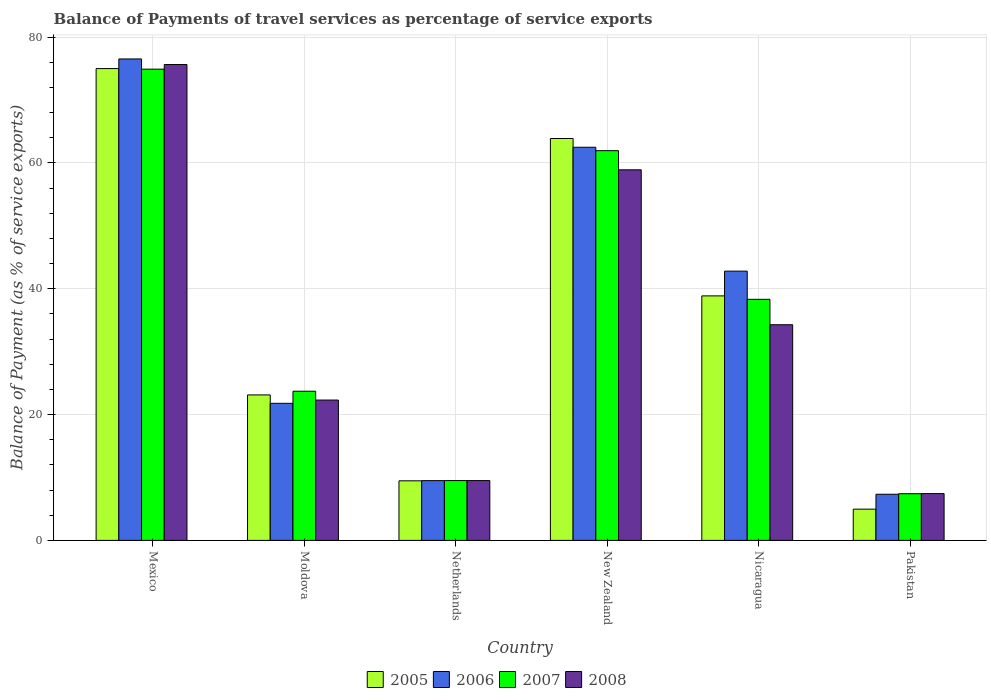How many different coloured bars are there?
Your answer should be compact. 4. How many groups of bars are there?
Give a very brief answer. 6. What is the label of the 2nd group of bars from the left?
Make the answer very short. Moldova. In how many cases, is the number of bars for a given country not equal to the number of legend labels?
Make the answer very short. 0. What is the balance of payments of travel services in 2006 in Nicaragua?
Make the answer very short. 42.81. Across all countries, what is the maximum balance of payments of travel services in 2006?
Your answer should be very brief. 76.54. Across all countries, what is the minimum balance of payments of travel services in 2008?
Your answer should be compact. 7.44. In which country was the balance of payments of travel services in 2005 minimum?
Offer a terse response. Pakistan. What is the total balance of payments of travel services in 2005 in the graph?
Provide a succinct answer. 215.34. What is the difference between the balance of payments of travel services in 2005 in Moldova and that in Nicaragua?
Offer a terse response. -15.74. What is the difference between the balance of payments of travel services in 2008 in New Zealand and the balance of payments of travel services in 2005 in Netherlands?
Your response must be concise. 49.44. What is the average balance of payments of travel services in 2008 per country?
Your response must be concise. 34.69. What is the difference between the balance of payments of travel services of/in 2005 and balance of payments of travel services of/in 2007 in New Zealand?
Offer a terse response. 1.93. What is the ratio of the balance of payments of travel services in 2005 in Netherlands to that in Pakistan?
Your answer should be very brief. 1.91. What is the difference between the highest and the second highest balance of payments of travel services in 2006?
Make the answer very short. -33.73. What is the difference between the highest and the lowest balance of payments of travel services in 2006?
Offer a very short reply. 69.21. In how many countries, is the balance of payments of travel services in 2007 greater than the average balance of payments of travel services in 2007 taken over all countries?
Provide a short and direct response. 3. What does the 4th bar from the left in Pakistan represents?
Provide a short and direct response. 2008. What does the 1st bar from the right in Nicaragua represents?
Provide a short and direct response. 2008. How many bars are there?
Your answer should be very brief. 24. How many countries are there in the graph?
Your answer should be very brief. 6. What is the difference between two consecutive major ticks on the Y-axis?
Offer a very short reply. 20. Are the values on the major ticks of Y-axis written in scientific E-notation?
Offer a terse response. No. How are the legend labels stacked?
Make the answer very short. Horizontal. What is the title of the graph?
Ensure brevity in your answer.  Balance of Payments of travel services as percentage of service exports. What is the label or title of the Y-axis?
Keep it short and to the point. Balance of Payment (as % of service exports). What is the Balance of Payment (as % of service exports) in 2005 in Mexico?
Your response must be concise. 75.01. What is the Balance of Payment (as % of service exports) in 2006 in Mexico?
Give a very brief answer. 76.54. What is the Balance of Payment (as % of service exports) in 2007 in Mexico?
Provide a succinct answer. 74.92. What is the Balance of Payment (as % of service exports) in 2008 in Mexico?
Your answer should be compact. 75.65. What is the Balance of Payment (as % of service exports) of 2005 in Moldova?
Give a very brief answer. 23.13. What is the Balance of Payment (as % of service exports) in 2006 in Moldova?
Give a very brief answer. 21.79. What is the Balance of Payment (as % of service exports) of 2007 in Moldova?
Your answer should be compact. 23.72. What is the Balance of Payment (as % of service exports) in 2008 in Moldova?
Your answer should be compact. 22.31. What is the Balance of Payment (as % of service exports) in 2005 in Netherlands?
Provide a succinct answer. 9.47. What is the Balance of Payment (as % of service exports) of 2006 in Netherlands?
Offer a terse response. 9.5. What is the Balance of Payment (as % of service exports) in 2007 in Netherlands?
Ensure brevity in your answer.  9.51. What is the Balance of Payment (as % of service exports) in 2008 in Netherlands?
Give a very brief answer. 9.51. What is the Balance of Payment (as % of service exports) in 2005 in New Zealand?
Provide a short and direct response. 63.89. What is the Balance of Payment (as % of service exports) in 2006 in New Zealand?
Provide a succinct answer. 62.5. What is the Balance of Payment (as % of service exports) in 2007 in New Zealand?
Provide a succinct answer. 61.96. What is the Balance of Payment (as % of service exports) of 2008 in New Zealand?
Keep it short and to the point. 58.91. What is the Balance of Payment (as % of service exports) of 2005 in Nicaragua?
Your answer should be compact. 38.87. What is the Balance of Payment (as % of service exports) in 2006 in Nicaragua?
Provide a short and direct response. 42.81. What is the Balance of Payment (as % of service exports) of 2007 in Nicaragua?
Your answer should be very brief. 38.33. What is the Balance of Payment (as % of service exports) of 2008 in Nicaragua?
Your response must be concise. 34.29. What is the Balance of Payment (as % of service exports) in 2005 in Pakistan?
Offer a terse response. 4.97. What is the Balance of Payment (as % of service exports) of 2006 in Pakistan?
Give a very brief answer. 7.34. What is the Balance of Payment (as % of service exports) in 2007 in Pakistan?
Give a very brief answer. 7.42. What is the Balance of Payment (as % of service exports) of 2008 in Pakistan?
Ensure brevity in your answer.  7.44. Across all countries, what is the maximum Balance of Payment (as % of service exports) of 2005?
Keep it short and to the point. 75.01. Across all countries, what is the maximum Balance of Payment (as % of service exports) of 2006?
Make the answer very short. 76.54. Across all countries, what is the maximum Balance of Payment (as % of service exports) in 2007?
Your answer should be very brief. 74.92. Across all countries, what is the maximum Balance of Payment (as % of service exports) in 2008?
Offer a very short reply. 75.65. Across all countries, what is the minimum Balance of Payment (as % of service exports) in 2005?
Offer a very short reply. 4.97. Across all countries, what is the minimum Balance of Payment (as % of service exports) of 2006?
Make the answer very short. 7.34. Across all countries, what is the minimum Balance of Payment (as % of service exports) of 2007?
Make the answer very short. 7.42. Across all countries, what is the minimum Balance of Payment (as % of service exports) in 2008?
Make the answer very short. 7.44. What is the total Balance of Payment (as % of service exports) of 2005 in the graph?
Keep it short and to the point. 215.34. What is the total Balance of Payment (as % of service exports) of 2006 in the graph?
Your answer should be very brief. 220.48. What is the total Balance of Payment (as % of service exports) of 2007 in the graph?
Provide a succinct answer. 215.85. What is the total Balance of Payment (as % of service exports) in 2008 in the graph?
Offer a very short reply. 208.11. What is the difference between the Balance of Payment (as % of service exports) of 2005 in Mexico and that in Moldova?
Ensure brevity in your answer.  51.88. What is the difference between the Balance of Payment (as % of service exports) of 2006 in Mexico and that in Moldova?
Provide a short and direct response. 54.75. What is the difference between the Balance of Payment (as % of service exports) of 2007 in Mexico and that in Moldova?
Your response must be concise. 51.2. What is the difference between the Balance of Payment (as % of service exports) of 2008 in Mexico and that in Moldova?
Offer a very short reply. 53.34. What is the difference between the Balance of Payment (as % of service exports) in 2005 in Mexico and that in Netherlands?
Your response must be concise. 65.54. What is the difference between the Balance of Payment (as % of service exports) of 2006 in Mexico and that in Netherlands?
Keep it short and to the point. 67.04. What is the difference between the Balance of Payment (as % of service exports) in 2007 in Mexico and that in Netherlands?
Offer a terse response. 65.41. What is the difference between the Balance of Payment (as % of service exports) of 2008 in Mexico and that in Netherlands?
Your answer should be very brief. 66.14. What is the difference between the Balance of Payment (as % of service exports) in 2005 in Mexico and that in New Zealand?
Give a very brief answer. 11.12. What is the difference between the Balance of Payment (as % of service exports) in 2006 in Mexico and that in New Zealand?
Your response must be concise. 14.04. What is the difference between the Balance of Payment (as % of service exports) of 2007 in Mexico and that in New Zealand?
Offer a terse response. 12.96. What is the difference between the Balance of Payment (as % of service exports) in 2008 in Mexico and that in New Zealand?
Keep it short and to the point. 16.74. What is the difference between the Balance of Payment (as % of service exports) of 2005 in Mexico and that in Nicaragua?
Your answer should be compact. 36.14. What is the difference between the Balance of Payment (as % of service exports) in 2006 in Mexico and that in Nicaragua?
Your answer should be very brief. 33.73. What is the difference between the Balance of Payment (as % of service exports) of 2007 in Mexico and that in Nicaragua?
Keep it short and to the point. 36.59. What is the difference between the Balance of Payment (as % of service exports) of 2008 in Mexico and that in Nicaragua?
Your response must be concise. 41.37. What is the difference between the Balance of Payment (as % of service exports) of 2005 in Mexico and that in Pakistan?
Ensure brevity in your answer.  70.04. What is the difference between the Balance of Payment (as % of service exports) of 2006 in Mexico and that in Pakistan?
Keep it short and to the point. 69.21. What is the difference between the Balance of Payment (as % of service exports) of 2007 in Mexico and that in Pakistan?
Keep it short and to the point. 67.5. What is the difference between the Balance of Payment (as % of service exports) in 2008 in Mexico and that in Pakistan?
Offer a very short reply. 68.21. What is the difference between the Balance of Payment (as % of service exports) in 2005 in Moldova and that in Netherlands?
Make the answer very short. 13.66. What is the difference between the Balance of Payment (as % of service exports) in 2006 in Moldova and that in Netherlands?
Provide a short and direct response. 12.29. What is the difference between the Balance of Payment (as % of service exports) in 2007 in Moldova and that in Netherlands?
Offer a very short reply. 14.21. What is the difference between the Balance of Payment (as % of service exports) of 2008 in Moldova and that in Netherlands?
Your response must be concise. 12.8. What is the difference between the Balance of Payment (as % of service exports) of 2005 in Moldova and that in New Zealand?
Keep it short and to the point. -40.76. What is the difference between the Balance of Payment (as % of service exports) of 2006 in Moldova and that in New Zealand?
Your response must be concise. -40.71. What is the difference between the Balance of Payment (as % of service exports) in 2007 in Moldova and that in New Zealand?
Make the answer very short. -38.24. What is the difference between the Balance of Payment (as % of service exports) in 2008 in Moldova and that in New Zealand?
Your answer should be very brief. -36.6. What is the difference between the Balance of Payment (as % of service exports) of 2005 in Moldova and that in Nicaragua?
Ensure brevity in your answer.  -15.74. What is the difference between the Balance of Payment (as % of service exports) of 2006 in Moldova and that in Nicaragua?
Offer a very short reply. -21.01. What is the difference between the Balance of Payment (as % of service exports) of 2007 in Moldova and that in Nicaragua?
Give a very brief answer. -14.61. What is the difference between the Balance of Payment (as % of service exports) of 2008 in Moldova and that in Nicaragua?
Keep it short and to the point. -11.97. What is the difference between the Balance of Payment (as % of service exports) in 2005 in Moldova and that in Pakistan?
Make the answer very short. 18.16. What is the difference between the Balance of Payment (as % of service exports) in 2006 in Moldova and that in Pakistan?
Keep it short and to the point. 14.46. What is the difference between the Balance of Payment (as % of service exports) in 2007 in Moldova and that in Pakistan?
Offer a very short reply. 16.3. What is the difference between the Balance of Payment (as % of service exports) of 2008 in Moldova and that in Pakistan?
Your answer should be compact. 14.87. What is the difference between the Balance of Payment (as % of service exports) in 2005 in Netherlands and that in New Zealand?
Your answer should be very brief. -54.42. What is the difference between the Balance of Payment (as % of service exports) in 2006 in Netherlands and that in New Zealand?
Keep it short and to the point. -53. What is the difference between the Balance of Payment (as % of service exports) in 2007 in Netherlands and that in New Zealand?
Offer a terse response. -52.45. What is the difference between the Balance of Payment (as % of service exports) of 2008 in Netherlands and that in New Zealand?
Ensure brevity in your answer.  -49.41. What is the difference between the Balance of Payment (as % of service exports) in 2005 in Netherlands and that in Nicaragua?
Provide a short and direct response. -29.4. What is the difference between the Balance of Payment (as % of service exports) in 2006 in Netherlands and that in Nicaragua?
Your response must be concise. -33.31. What is the difference between the Balance of Payment (as % of service exports) of 2007 in Netherlands and that in Nicaragua?
Your answer should be very brief. -28.82. What is the difference between the Balance of Payment (as % of service exports) in 2008 in Netherlands and that in Nicaragua?
Your answer should be very brief. -24.78. What is the difference between the Balance of Payment (as % of service exports) in 2005 in Netherlands and that in Pakistan?
Offer a terse response. 4.51. What is the difference between the Balance of Payment (as % of service exports) of 2006 in Netherlands and that in Pakistan?
Your answer should be very brief. 2.16. What is the difference between the Balance of Payment (as % of service exports) in 2007 in Netherlands and that in Pakistan?
Your answer should be compact. 2.09. What is the difference between the Balance of Payment (as % of service exports) of 2008 in Netherlands and that in Pakistan?
Your answer should be compact. 2.07. What is the difference between the Balance of Payment (as % of service exports) of 2005 in New Zealand and that in Nicaragua?
Your answer should be compact. 25.02. What is the difference between the Balance of Payment (as % of service exports) in 2006 in New Zealand and that in Nicaragua?
Your response must be concise. 19.69. What is the difference between the Balance of Payment (as % of service exports) of 2007 in New Zealand and that in Nicaragua?
Your answer should be compact. 23.63. What is the difference between the Balance of Payment (as % of service exports) in 2008 in New Zealand and that in Nicaragua?
Your answer should be very brief. 24.63. What is the difference between the Balance of Payment (as % of service exports) in 2005 in New Zealand and that in Pakistan?
Ensure brevity in your answer.  58.93. What is the difference between the Balance of Payment (as % of service exports) in 2006 in New Zealand and that in Pakistan?
Your answer should be compact. 55.17. What is the difference between the Balance of Payment (as % of service exports) in 2007 in New Zealand and that in Pakistan?
Ensure brevity in your answer.  54.54. What is the difference between the Balance of Payment (as % of service exports) in 2008 in New Zealand and that in Pakistan?
Provide a succinct answer. 51.47. What is the difference between the Balance of Payment (as % of service exports) of 2005 in Nicaragua and that in Pakistan?
Provide a short and direct response. 33.91. What is the difference between the Balance of Payment (as % of service exports) in 2006 in Nicaragua and that in Pakistan?
Offer a very short reply. 35.47. What is the difference between the Balance of Payment (as % of service exports) in 2007 in Nicaragua and that in Pakistan?
Provide a short and direct response. 30.91. What is the difference between the Balance of Payment (as % of service exports) in 2008 in Nicaragua and that in Pakistan?
Offer a very short reply. 26.85. What is the difference between the Balance of Payment (as % of service exports) in 2005 in Mexico and the Balance of Payment (as % of service exports) in 2006 in Moldova?
Your answer should be compact. 53.22. What is the difference between the Balance of Payment (as % of service exports) in 2005 in Mexico and the Balance of Payment (as % of service exports) in 2007 in Moldova?
Provide a short and direct response. 51.29. What is the difference between the Balance of Payment (as % of service exports) in 2005 in Mexico and the Balance of Payment (as % of service exports) in 2008 in Moldova?
Keep it short and to the point. 52.7. What is the difference between the Balance of Payment (as % of service exports) of 2006 in Mexico and the Balance of Payment (as % of service exports) of 2007 in Moldova?
Your response must be concise. 52.82. What is the difference between the Balance of Payment (as % of service exports) in 2006 in Mexico and the Balance of Payment (as % of service exports) in 2008 in Moldova?
Provide a short and direct response. 54.23. What is the difference between the Balance of Payment (as % of service exports) of 2007 in Mexico and the Balance of Payment (as % of service exports) of 2008 in Moldova?
Make the answer very short. 52.61. What is the difference between the Balance of Payment (as % of service exports) in 2005 in Mexico and the Balance of Payment (as % of service exports) in 2006 in Netherlands?
Offer a very short reply. 65.51. What is the difference between the Balance of Payment (as % of service exports) of 2005 in Mexico and the Balance of Payment (as % of service exports) of 2007 in Netherlands?
Keep it short and to the point. 65.5. What is the difference between the Balance of Payment (as % of service exports) in 2005 in Mexico and the Balance of Payment (as % of service exports) in 2008 in Netherlands?
Your answer should be compact. 65.5. What is the difference between the Balance of Payment (as % of service exports) of 2006 in Mexico and the Balance of Payment (as % of service exports) of 2007 in Netherlands?
Provide a short and direct response. 67.03. What is the difference between the Balance of Payment (as % of service exports) of 2006 in Mexico and the Balance of Payment (as % of service exports) of 2008 in Netherlands?
Provide a short and direct response. 67.03. What is the difference between the Balance of Payment (as % of service exports) of 2007 in Mexico and the Balance of Payment (as % of service exports) of 2008 in Netherlands?
Ensure brevity in your answer.  65.41. What is the difference between the Balance of Payment (as % of service exports) in 2005 in Mexico and the Balance of Payment (as % of service exports) in 2006 in New Zealand?
Offer a terse response. 12.51. What is the difference between the Balance of Payment (as % of service exports) in 2005 in Mexico and the Balance of Payment (as % of service exports) in 2007 in New Zealand?
Your answer should be very brief. 13.05. What is the difference between the Balance of Payment (as % of service exports) in 2005 in Mexico and the Balance of Payment (as % of service exports) in 2008 in New Zealand?
Your answer should be compact. 16.09. What is the difference between the Balance of Payment (as % of service exports) of 2006 in Mexico and the Balance of Payment (as % of service exports) of 2007 in New Zealand?
Make the answer very short. 14.58. What is the difference between the Balance of Payment (as % of service exports) in 2006 in Mexico and the Balance of Payment (as % of service exports) in 2008 in New Zealand?
Keep it short and to the point. 17.63. What is the difference between the Balance of Payment (as % of service exports) of 2007 in Mexico and the Balance of Payment (as % of service exports) of 2008 in New Zealand?
Your response must be concise. 16. What is the difference between the Balance of Payment (as % of service exports) in 2005 in Mexico and the Balance of Payment (as % of service exports) in 2006 in Nicaragua?
Provide a short and direct response. 32.2. What is the difference between the Balance of Payment (as % of service exports) of 2005 in Mexico and the Balance of Payment (as % of service exports) of 2007 in Nicaragua?
Your response must be concise. 36.68. What is the difference between the Balance of Payment (as % of service exports) of 2005 in Mexico and the Balance of Payment (as % of service exports) of 2008 in Nicaragua?
Offer a terse response. 40.72. What is the difference between the Balance of Payment (as % of service exports) of 2006 in Mexico and the Balance of Payment (as % of service exports) of 2007 in Nicaragua?
Offer a terse response. 38.22. What is the difference between the Balance of Payment (as % of service exports) in 2006 in Mexico and the Balance of Payment (as % of service exports) in 2008 in Nicaragua?
Provide a succinct answer. 42.26. What is the difference between the Balance of Payment (as % of service exports) in 2007 in Mexico and the Balance of Payment (as % of service exports) in 2008 in Nicaragua?
Ensure brevity in your answer.  40.63. What is the difference between the Balance of Payment (as % of service exports) in 2005 in Mexico and the Balance of Payment (as % of service exports) in 2006 in Pakistan?
Your answer should be very brief. 67.67. What is the difference between the Balance of Payment (as % of service exports) in 2005 in Mexico and the Balance of Payment (as % of service exports) in 2007 in Pakistan?
Give a very brief answer. 67.59. What is the difference between the Balance of Payment (as % of service exports) of 2005 in Mexico and the Balance of Payment (as % of service exports) of 2008 in Pakistan?
Your answer should be compact. 67.57. What is the difference between the Balance of Payment (as % of service exports) of 2006 in Mexico and the Balance of Payment (as % of service exports) of 2007 in Pakistan?
Make the answer very short. 69.12. What is the difference between the Balance of Payment (as % of service exports) in 2006 in Mexico and the Balance of Payment (as % of service exports) in 2008 in Pakistan?
Give a very brief answer. 69.1. What is the difference between the Balance of Payment (as % of service exports) in 2007 in Mexico and the Balance of Payment (as % of service exports) in 2008 in Pakistan?
Your answer should be compact. 67.48. What is the difference between the Balance of Payment (as % of service exports) in 2005 in Moldova and the Balance of Payment (as % of service exports) in 2006 in Netherlands?
Make the answer very short. 13.63. What is the difference between the Balance of Payment (as % of service exports) in 2005 in Moldova and the Balance of Payment (as % of service exports) in 2007 in Netherlands?
Give a very brief answer. 13.62. What is the difference between the Balance of Payment (as % of service exports) in 2005 in Moldova and the Balance of Payment (as % of service exports) in 2008 in Netherlands?
Provide a succinct answer. 13.62. What is the difference between the Balance of Payment (as % of service exports) of 2006 in Moldova and the Balance of Payment (as % of service exports) of 2007 in Netherlands?
Your answer should be very brief. 12.28. What is the difference between the Balance of Payment (as % of service exports) of 2006 in Moldova and the Balance of Payment (as % of service exports) of 2008 in Netherlands?
Your answer should be very brief. 12.28. What is the difference between the Balance of Payment (as % of service exports) of 2007 in Moldova and the Balance of Payment (as % of service exports) of 2008 in Netherlands?
Provide a succinct answer. 14.21. What is the difference between the Balance of Payment (as % of service exports) in 2005 in Moldova and the Balance of Payment (as % of service exports) in 2006 in New Zealand?
Offer a very short reply. -39.37. What is the difference between the Balance of Payment (as % of service exports) in 2005 in Moldova and the Balance of Payment (as % of service exports) in 2007 in New Zealand?
Keep it short and to the point. -38.83. What is the difference between the Balance of Payment (as % of service exports) of 2005 in Moldova and the Balance of Payment (as % of service exports) of 2008 in New Zealand?
Provide a succinct answer. -35.79. What is the difference between the Balance of Payment (as % of service exports) of 2006 in Moldova and the Balance of Payment (as % of service exports) of 2007 in New Zealand?
Your answer should be compact. -40.16. What is the difference between the Balance of Payment (as % of service exports) of 2006 in Moldova and the Balance of Payment (as % of service exports) of 2008 in New Zealand?
Keep it short and to the point. -37.12. What is the difference between the Balance of Payment (as % of service exports) of 2007 in Moldova and the Balance of Payment (as % of service exports) of 2008 in New Zealand?
Offer a terse response. -35.2. What is the difference between the Balance of Payment (as % of service exports) of 2005 in Moldova and the Balance of Payment (as % of service exports) of 2006 in Nicaragua?
Your response must be concise. -19.68. What is the difference between the Balance of Payment (as % of service exports) in 2005 in Moldova and the Balance of Payment (as % of service exports) in 2007 in Nicaragua?
Give a very brief answer. -15.2. What is the difference between the Balance of Payment (as % of service exports) in 2005 in Moldova and the Balance of Payment (as % of service exports) in 2008 in Nicaragua?
Offer a terse response. -11.16. What is the difference between the Balance of Payment (as % of service exports) of 2006 in Moldova and the Balance of Payment (as % of service exports) of 2007 in Nicaragua?
Offer a terse response. -16.53. What is the difference between the Balance of Payment (as % of service exports) in 2006 in Moldova and the Balance of Payment (as % of service exports) in 2008 in Nicaragua?
Provide a short and direct response. -12.49. What is the difference between the Balance of Payment (as % of service exports) of 2007 in Moldova and the Balance of Payment (as % of service exports) of 2008 in Nicaragua?
Your response must be concise. -10.57. What is the difference between the Balance of Payment (as % of service exports) in 2005 in Moldova and the Balance of Payment (as % of service exports) in 2006 in Pakistan?
Offer a terse response. 15.79. What is the difference between the Balance of Payment (as % of service exports) in 2005 in Moldova and the Balance of Payment (as % of service exports) in 2007 in Pakistan?
Provide a succinct answer. 15.71. What is the difference between the Balance of Payment (as % of service exports) in 2005 in Moldova and the Balance of Payment (as % of service exports) in 2008 in Pakistan?
Offer a very short reply. 15.69. What is the difference between the Balance of Payment (as % of service exports) in 2006 in Moldova and the Balance of Payment (as % of service exports) in 2007 in Pakistan?
Your response must be concise. 14.37. What is the difference between the Balance of Payment (as % of service exports) in 2006 in Moldova and the Balance of Payment (as % of service exports) in 2008 in Pakistan?
Make the answer very short. 14.35. What is the difference between the Balance of Payment (as % of service exports) of 2007 in Moldova and the Balance of Payment (as % of service exports) of 2008 in Pakistan?
Ensure brevity in your answer.  16.28. What is the difference between the Balance of Payment (as % of service exports) of 2005 in Netherlands and the Balance of Payment (as % of service exports) of 2006 in New Zealand?
Offer a very short reply. -53.03. What is the difference between the Balance of Payment (as % of service exports) in 2005 in Netherlands and the Balance of Payment (as % of service exports) in 2007 in New Zealand?
Make the answer very short. -52.49. What is the difference between the Balance of Payment (as % of service exports) of 2005 in Netherlands and the Balance of Payment (as % of service exports) of 2008 in New Zealand?
Provide a succinct answer. -49.44. What is the difference between the Balance of Payment (as % of service exports) in 2006 in Netherlands and the Balance of Payment (as % of service exports) in 2007 in New Zealand?
Make the answer very short. -52.46. What is the difference between the Balance of Payment (as % of service exports) in 2006 in Netherlands and the Balance of Payment (as % of service exports) in 2008 in New Zealand?
Give a very brief answer. -49.42. What is the difference between the Balance of Payment (as % of service exports) in 2007 in Netherlands and the Balance of Payment (as % of service exports) in 2008 in New Zealand?
Your answer should be compact. -49.41. What is the difference between the Balance of Payment (as % of service exports) of 2005 in Netherlands and the Balance of Payment (as % of service exports) of 2006 in Nicaragua?
Provide a succinct answer. -33.34. What is the difference between the Balance of Payment (as % of service exports) of 2005 in Netherlands and the Balance of Payment (as % of service exports) of 2007 in Nicaragua?
Your response must be concise. -28.85. What is the difference between the Balance of Payment (as % of service exports) of 2005 in Netherlands and the Balance of Payment (as % of service exports) of 2008 in Nicaragua?
Ensure brevity in your answer.  -24.81. What is the difference between the Balance of Payment (as % of service exports) in 2006 in Netherlands and the Balance of Payment (as % of service exports) in 2007 in Nicaragua?
Ensure brevity in your answer.  -28.83. What is the difference between the Balance of Payment (as % of service exports) of 2006 in Netherlands and the Balance of Payment (as % of service exports) of 2008 in Nicaragua?
Your answer should be very brief. -24.79. What is the difference between the Balance of Payment (as % of service exports) in 2007 in Netherlands and the Balance of Payment (as % of service exports) in 2008 in Nicaragua?
Keep it short and to the point. -24.78. What is the difference between the Balance of Payment (as % of service exports) of 2005 in Netherlands and the Balance of Payment (as % of service exports) of 2006 in Pakistan?
Make the answer very short. 2.14. What is the difference between the Balance of Payment (as % of service exports) in 2005 in Netherlands and the Balance of Payment (as % of service exports) in 2007 in Pakistan?
Give a very brief answer. 2.05. What is the difference between the Balance of Payment (as % of service exports) in 2005 in Netherlands and the Balance of Payment (as % of service exports) in 2008 in Pakistan?
Your answer should be very brief. 2.03. What is the difference between the Balance of Payment (as % of service exports) of 2006 in Netherlands and the Balance of Payment (as % of service exports) of 2007 in Pakistan?
Give a very brief answer. 2.08. What is the difference between the Balance of Payment (as % of service exports) in 2006 in Netherlands and the Balance of Payment (as % of service exports) in 2008 in Pakistan?
Make the answer very short. 2.06. What is the difference between the Balance of Payment (as % of service exports) in 2007 in Netherlands and the Balance of Payment (as % of service exports) in 2008 in Pakistan?
Your answer should be very brief. 2.07. What is the difference between the Balance of Payment (as % of service exports) in 2005 in New Zealand and the Balance of Payment (as % of service exports) in 2006 in Nicaragua?
Offer a very short reply. 21.09. What is the difference between the Balance of Payment (as % of service exports) of 2005 in New Zealand and the Balance of Payment (as % of service exports) of 2007 in Nicaragua?
Offer a terse response. 25.57. What is the difference between the Balance of Payment (as % of service exports) in 2005 in New Zealand and the Balance of Payment (as % of service exports) in 2008 in Nicaragua?
Your answer should be very brief. 29.61. What is the difference between the Balance of Payment (as % of service exports) of 2006 in New Zealand and the Balance of Payment (as % of service exports) of 2007 in Nicaragua?
Ensure brevity in your answer.  24.18. What is the difference between the Balance of Payment (as % of service exports) in 2006 in New Zealand and the Balance of Payment (as % of service exports) in 2008 in Nicaragua?
Offer a terse response. 28.21. What is the difference between the Balance of Payment (as % of service exports) of 2007 in New Zealand and the Balance of Payment (as % of service exports) of 2008 in Nicaragua?
Keep it short and to the point. 27.67. What is the difference between the Balance of Payment (as % of service exports) in 2005 in New Zealand and the Balance of Payment (as % of service exports) in 2006 in Pakistan?
Offer a very short reply. 56.56. What is the difference between the Balance of Payment (as % of service exports) of 2005 in New Zealand and the Balance of Payment (as % of service exports) of 2007 in Pakistan?
Provide a short and direct response. 56.47. What is the difference between the Balance of Payment (as % of service exports) of 2005 in New Zealand and the Balance of Payment (as % of service exports) of 2008 in Pakistan?
Offer a terse response. 56.45. What is the difference between the Balance of Payment (as % of service exports) of 2006 in New Zealand and the Balance of Payment (as % of service exports) of 2007 in Pakistan?
Ensure brevity in your answer.  55.08. What is the difference between the Balance of Payment (as % of service exports) in 2006 in New Zealand and the Balance of Payment (as % of service exports) in 2008 in Pakistan?
Your answer should be very brief. 55.06. What is the difference between the Balance of Payment (as % of service exports) of 2007 in New Zealand and the Balance of Payment (as % of service exports) of 2008 in Pakistan?
Provide a short and direct response. 54.52. What is the difference between the Balance of Payment (as % of service exports) in 2005 in Nicaragua and the Balance of Payment (as % of service exports) in 2006 in Pakistan?
Provide a succinct answer. 31.54. What is the difference between the Balance of Payment (as % of service exports) in 2005 in Nicaragua and the Balance of Payment (as % of service exports) in 2007 in Pakistan?
Offer a very short reply. 31.46. What is the difference between the Balance of Payment (as % of service exports) in 2005 in Nicaragua and the Balance of Payment (as % of service exports) in 2008 in Pakistan?
Ensure brevity in your answer.  31.43. What is the difference between the Balance of Payment (as % of service exports) of 2006 in Nicaragua and the Balance of Payment (as % of service exports) of 2007 in Pakistan?
Offer a very short reply. 35.39. What is the difference between the Balance of Payment (as % of service exports) of 2006 in Nicaragua and the Balance of Payment (as % of service exports) of 2008 in Pakistan?
Give a very brief answer. 35.37. What is the difference between the Balance of Payment (as % of service exports) in 2007 in Nicaragua and the Balance of Payment (as % of service exports) in 2008 in Pakistan?
Your response must be concise. 30.89. What is the average Balance of Payment (as % of service exports) of 2005 per country?
Make the answer very short. 35.89. What is the average Balance of Payment (as % of service exports) in 2006 per country?
Provide a short and direct response. 36.75. What is the average Balance of Payment (as % of service exports) in 2007 per country?
Keep it short and to the point. 35.97. What is the average Balance of Payment (as % of service exports) in 2008 per country?
Your response must be concise. 34.69. What is the difference between the Balance of Payment (as % of service exports) in 2005 and Balance of Payment (as % of service exports) in 2006 in Mexico?
Provide a short and direct response. -1.53. What is the difference between the Balance of Payment (as % of service exports) of 2005 and Balance of Payment (as % of service exports) of 2007 in Mexico?
Your response must be concise. 0.09. What is the difference between the Balance of Payment (as % of service exports) of 2005 and Balance of Payment (as % of service exports) of 2008 in Mexico?
Offer a terse response. -0.64. What is the difference between the Balance of Payment (as % of service exports) of 2006 and Balance of Payment (as % of service exports) of 2007 in Mexico?
Keep it short and to the point. 1.62. What is the difference between the Balance of Payment (as % of service exports) of 2006 and Balance of Payment (as % of service exports) of 2008 in Mexico?
Keep it short and to the point. 0.89. What is the difference between the Balance of Payment (as % of service exports) in 2007 and Balance of Payment (as % of service exports) in 2008 in Mexico?
Keep it short and to the point. -0.73. What is the difference between the Balance of Payment (as % of service exports) of 2005 and Balance of Payment (as % of service exports) of 2006 in Moldova?
Give a very brief answer. 1.34. What is the difference between the Balance of Payment (as % of service exports) of 2005 and Balance of Payment (as % of service exports) of 2007 in Moldova?
Your response must be concise. -0.59. What is the difference between the Balance of Payment (as % of service exports) of 2005 and Balance of Payment (as % of service exports) of 2008 in Moldova?
Provide a short and direct response. 0.82. What is the difference between the Balance of Payment (as % of service exports) in 2006 and Balance of Payment (as % of service exports) in 2007 in Moldova?
Offer a terse response. -1.92. What is the difference between the Balance of Payment (as % of service exports) in 2006 and Balance of Payment (as % of service exports) in 2008 in Moldova?
Your answer should be compact. -0.52. What is the difference between the Balance of Payment (as % of service exports) in 2007 and Balance of Payment (as % of service exports) in 2008 in Moldova?
Ensure brevity in your answer.  1.41. What is the difference between the Balance of Payment (as % of service exports) in 2005 and Balance of Payment (as % of service exports) in 2006 in Netherlands?
Your response must be concise. -0.03. What is the difference between the Balance of Payment (as % of service exports) of 2005 and Balance of Payment (as % of service exports) of 2007 in Netherlands?
Provide a short and direct response. -0.04. What is the difference between the Balance of Payment (as % of service exports) of 2005 and Balance of Payment (as % of service exports) of 2008 in Netherlands?
Make the answer very short. -0.04. What is the difference between the Balance of Payment (as % of service exports) in 2006 and Balance of Payment (as % of service exports) in 2007 in Netherlands?
Keep it short and to the point. -0.01. What is the difference between the Balance of Payment (as % of service exports) of 2006 and Balance of Payment (as % of service exports) of 2008 in Netherlands?
Your answer should be very brief. -0.01. What is the difference between the Balance of Payment (as % of service exports) in 2007 and Balance of Payment (as % of service exports) in 2008 in Netherlands?
Make the answer very short. -0. What is the difference between the Balance of Payment (as % of service exports) in 2005 and Balance of Payment (as % of service exports) in 2006 in New Zealand?
Your answer should be very brief. 1.39. What is the difference between the Balance of Payment (as % of service exports) of 2005 and Balance of Payment (as % of service exports) of 2007 in New Zealand?
Keep it short and to the point. 1.93. What is the difference between the Balance of Payment (as % of service exports) in 2005 and Balance of Payment (as % of service exports) in 2008 in New Zealand?
Ensure brevity in your answer.  4.98. What is the difference between the Balance of Payment (as % of service exports) of 2006 and Balance of Payment (as % of service exports) of 2007 in New Zealand?
Offer a very short reply. 0.54. What is the difference between the Balance of Payment (as % of service exports) of 2006 and Balance of Payment (as % of service exports) of 2008 in New Zealand?
Keep it short and to the point. 3.59. What is the difference between the Balance of Payment (as % of service exports) of 2007 and Balance of Payment (as % of service exports) of 2008 in New Zealand?
Provide a short and direct response. 3.04. What is the difference between the Balance of Payment (as % of service exports) of 2005 and Balance of Payment (as % of service exports) of 2006 in Nicaragua?
Your response must be concise. -3.93. What is the difference between the Balance of Payment (as % of service exports) of 2005 and Balance of Payment (as % of service exports) of 2007 in Nicaragua?
Offer a very short reply. 0.55. What is the difference between the Balance of Payment (as % of service exports) of 2005 and Balance of Payment (as % of service exports) of 2008 in Nicaragua?
Give a very brief answer. 4.59. What is the difference between the Balance of Payment (as % of service exports) of 2006 and Balance of Payment (as % of service exports) of 2007 in Nicaragua?
Provide a short and direct response. 4.48. What is the difference between the Balance of Payment (as % of service exports) in 2006 and Balance of Payment (as % of service exports) in 2008 in Nicaragua?
Provide a short and direct response. 8.52. What is the difference between the Balance of Payment (as % of service exports) of 2007 and Balance of Payment (as % of service exports) of 2008 in Nicaragua?
Give a very brief answer. 4.04. What is the difference between the Balance of Payment (as % of service exports) of 2005 and Balance of Payment (as % of service exports) of 2006 in Pakistan?
Provide a succinct answer. -2.37. What is the difference between the Balance of Payment (as % of service exports) in 2005 and Balance of Payment (as % of service exports) in 2007 in Pakistan?
Your answer should be compact. -2.45. What is the difference between the Balance of Payment (as % of service exports) in 2005 and Balance of Payment (as % of service exports) in 2008 in Pakistan?
Give a very brief answer. -2.47. What is the difference between the Balance of Payment (as % of service exports) in 2006 and Balance of Payment (as % of service exports) in 2007 in Pakistan?
Provide a short and direct response. -0.08. What is the difference between the Balance of Payment (as % of service exports) of 2006 and Balance of Payment (as % of service exports) of 2008 in Pakistan?
Your answer should be compact. -0.1. What is the difference between the Balance of Payment (as % of service exports) in 2007 and Balance of Payment (as % of service exports) in 2008 in Pakistan?
Give a very brief answer. -0.02. What is the ratio of the Balance of Payment (as % of service exports) of 2005 in Mexico to that in Moldova?
Offer a very short reply. 3.24. What is the ratio of the Balance of Payment (as % of service exports) in 2006 in Mexico to that in Moldova?
Your answer should be compact. 3.51. What is the ratio of the Balance of Payment (as % of service exports) of 2007 in Mexico to that in Moldova?
Provide a short and direct response. 3.16. What is the ratio of the Balance of Payment (as % of service exports) of 2008 in Mexico to that in Moldova?
Your answer should be very brief. 3.39. What is the ratio of the Balance of Payment (as % of service exports) of 2005 in Mexico to that in Netherlands?
Keep it short and to the point. 7.92. What is the ratio of the Balance of Payment (as % of service exports) of 2006 in Mexico to that in Netherlands?
Provide a succinct answer. 8.06. What is the ratio of the Balance of Payment (as % of service exports) of 2007 in Mexico to that in Netherlands?
Your answer should be compact. 7.88. What is the ratio of the Balance of Payment (as % of service exports) in 2008 in Mexico to that in Netherlands?
Offer a terse response. 7.96. What is the ratio of the Balance of Payment (as % of service exports) in 2005 in Mexico to that in New Zealand?
Provide a succinct answer. 1.17. What is the ratio of the Balance of Payment (as % of service exports) of 2006 in Mexico to that in New Zealand?
Keep it short and to the point. 1.22. What is the ratio of the Balance of Payment (as % of service exports) in 2007 in Mexico to that in New Zealand?
Offer a terse response. 1.21. What is the ratio of the Balance of Payment (as % of service exports) of 2008 in Mexico to that in New Zealand?
Keep it short and to the point. 1.28. What is the ratio of the Balance of Payment (as % of service exports) of 2005 in Mexico to that in Nicaragua?
Provide a succinct answer. 1.93. What is the ratio of the Balance of Payment (as % of service exports) of 2006 in Mexico to that in Nicaragua?
Your answer should be compact. 1.79. What is the ratio of the Balance of Payment (as % of service exports) of 2007 in Mexico to that in Nicaragua?
Offer a very short reply. 1.95. What is the ratio of the Balance of Payment (as % of service exports) in 2008 in Mexico to that in Nicaragua?
Keep it short and to the point. 2.21. What is the ratio of the Balance of Payment (as % of service exports) of 2005 in Mexico to that in Pakistan?
Keep it short and to the point. 15.1. What is the ratio of the Balance of Payment (as % of service exports) of 2006 in Mexico to that in Pakistan?
Your answer should be very brief. 10.43. What is the ratio of the Balance of Payment (as % of service exports) of 2007 in Mexico to that in Pakistan?
Give a very brief answer. 10.1. What is the ratio of the Balance of Payment (as % of service exports) in 2008 in Mexico to that in Pakistan?
Offer a very short reply. 10.17. What is the ratio of the Balance of Payment (as % of service exports) in 2005 in Moldova to that in Netherlands?
Make the answer very short. 2.44. What is the ratio of the Balance of Payment (as % of service exports) in 2006 in Moldova to that in Netherlands?
Your response must be concise. 2.29. What is the ratio of the Balance of Payment (as % of service exports) of 2007 in Moldova to that in Netherlands?
Your answer should be compact. 2.49. What is the ratio of the Balance of Payment (as % of service exports) in 2008 in Moldova to that in Netherlands?
Your answer should be very brief. 2.35. What is the ratio of the Balance of Payment (as % of service exports) in 2005 in Moldova to that in New Zealand?
Your response must be concise. 0.36. What is the ratio of the Balance of Payment (as % of service exports) in 2006 in Moldova to that in New Zealand?
Your answer should be very brief. 0.35. What is the ratio of the Balance of Payment (as % of service exports) of 2007 in Moldova to that in New Zealand?
Provide a short and direct response. 0.38. What is the ratio of the Balance of Payment (as % of service exports) in 2008 in Moldova to that in New Zealand?
Your response must be concise. 0.38. What is the ratio of the Balance of Payment (as % of service exports) in 2005 in Moldova to that in Nicaragua?
Your answer should be very brief. 0.59. What is the ratio of the Balance of Payment (as % of service exports) in 2006 in Moldova to that in Nicaragua?
Offer a very short reply. 0.51. What is the ratio of the Balance of Payment (as % of service exports) of 2007 in Moldova to that in Nicaragua?
Your answer should be very brief. 0.62. What is the ratio of the Balance of Payment (as % of service exports) in 2008 in Moldova to that in Nicaragua?
Offer a very short reply. 0.65. What is the ratio of the Balance of Payment (as % of service exports) of 2005 in Moldova to that in Pakistan?
Give a very brief answer. 4.66. What is the ratio of the Balance of Payment (as % of service exports) in 2006 in Moldova to that in Pakistan?
Keep it short and to the point. 2.97. What is the ratio of the Balance of Payment (as % of service exports) in 2007 in Moldova to that in Pakistan?
Offer a very short reply. 3.2. What is the ratio of the Balance of Payment (as % of service exports) of 2008 in Moldova to that in Pakistan?
Make the answer very short. 3. What is the ratio of the Balance of Payment (as % of service exports) in 2005 in Netherlands to that in New Zealand?
Provide a succinct answer. 0.15. What is the ratio of the Balance of Payment (as % of service exports) in 2006 in Netherlands to that in New Zealand?
Your response must be concise. 0.15. What is the ratio of the Balance of Payment (as % of service exports) of 2007 in Netherlands to that in New Zealand?
Your response must be concise. 0.15. What is the ratio of the Balance of Payment (as % of service exports) of 2008 in Netherlands to that in New Zealand?
Ensure brevity in your answer.  0.16. What is the ratio of the Balance of Payment (as % of service exports) of 2005 in Netherlands to that in Nicaragua?
Provide a succinct answer. 0.24. What is the ratio of the Balance of Payment (as % of service exports) in 2006 in Netherlands to that in Nicaragua?
Provide a short and direct response. 0.22. What is the ratio of the Balance of Payment (as % of service exports) of 2007 in Netherlands to that in Nicaragua?
Offer a terse response. 0.25. What is the ratio of the Balance of Payment (as % of service exports) in 2008 in Netherlands to that in Nicaragua?
Provide a short and direct response. 0.28. What is the ratio of the Balance of Payment (as % of service exports) in 2005 in Netherlands to that in Pakistan?
Keep it short and to the point. 1.91. What is the ratio of the Balance of Payment (as % of service exports) of 2006 in Netherlands to that in Pakistan?
Provide a succinct answer. 1.29. What is the ratio of the Balance of Payment (as % of service exports) in 2007 in Netherlands to that in Pakistan?
Your response must be concise. 1.28. What is the ratio of the Balance of Payment (as % of service exports) in 2008 in Netherlands to that in Pakistan?
Ensure brevity in your answer.  1.28. What is the ratio of the Balance of Payment (as % of service exports) of 2005 in New Zealand to that in Nicaragua?
Your answer should be very brief. 1.64. What is the ratio of the Balance of Payment (as % of service exports) in 2006 in New Zealand to that in Nicaragua?
Your response must be concise. 1.46. What is the ratio of the Balance of Payment (as % of service exports) in 2007 in New Zealand to that in Nicaragua?
Your answer should be very brief. 1.62. What is the ratio of the Balance of Payment (as % of service exports) in 2008 in New Zealand to that in Nicaragua?
Make the answer very short. 1.72. What is the ratio of the Balance of Payment (as % of service exports) in 2005 in New Zealand to that in Pakistan?
Make the answer very short. 12.87. What is the ratio of the Balance of Payment (as % of service exports) in 2006 in New Zealand to that in Pakistan?
Ensure brevity in your answer.  8.52. What is the ratio of the Balance of Payment (as % of service exports) of 2007 in New Zealand to that in Pakistan?
Make the answer very short. 8.35. What is the ratio of the Balance of Payment (as % of service exports) in 2008 in New Zealand to that in Pakistan?
Offer a terse response. 7.92. What is the ratio of the Balance of Payment (as % of service exports) in 2005 in Nicaragua to that in Pakistan?
Offer a very short reply. 7.83. What is the ratio of the Balance of Payment (as % of service exports) in 2006 in Nicaragua to that in Pakistan?
Give a very brief answer. 5.84. What is the ratio of the Balance of Payment (as % of service exports) in 2007 in Nicaragua to that in Pakistan?
Make the answer very short. 5.17. What is the ratio of the Balance of Payment (as % of service exports) of 2008 in Nicaragua to that in Pakistan?
Offer a very short reply. 4.61. What is the difference between the highest and the second highest Balance of Payment (as % of service exports) of 2005?
Your answer should be very brief. 11.12. What is the difference between the highest and the second highest Balance of Payment (as % of service exports) of 2006?
Your answer should be compact. 14.04. What is the difference between the highest and the second highest Balance of Payment (as % of service exports) in 2007?
Keep it short and to the point. 12.96. What is the difference between the highest and the second highest Balance of Payment (as % of service exports) in 2008?
Your response must be concise. 16.74. What is the difference between the highest and the lowest Balance of Payment (as % of service exports) in 2005?
Ensure brevity in your answer.  70.04. What is the difference between the highest and the lowest Balance of Payment (as % of service exports) in 2006?
Provide a succinct answer. 69.21. What is the difference between the highest and the lowest Balance of Payment (as % of service exports) in 2007?
Your answer should be compact. 67.5. What is the difference between the highest and the lowest Balance of Payment (as % of service exports) of 2008?
Your answer should be compact. 68.21. 